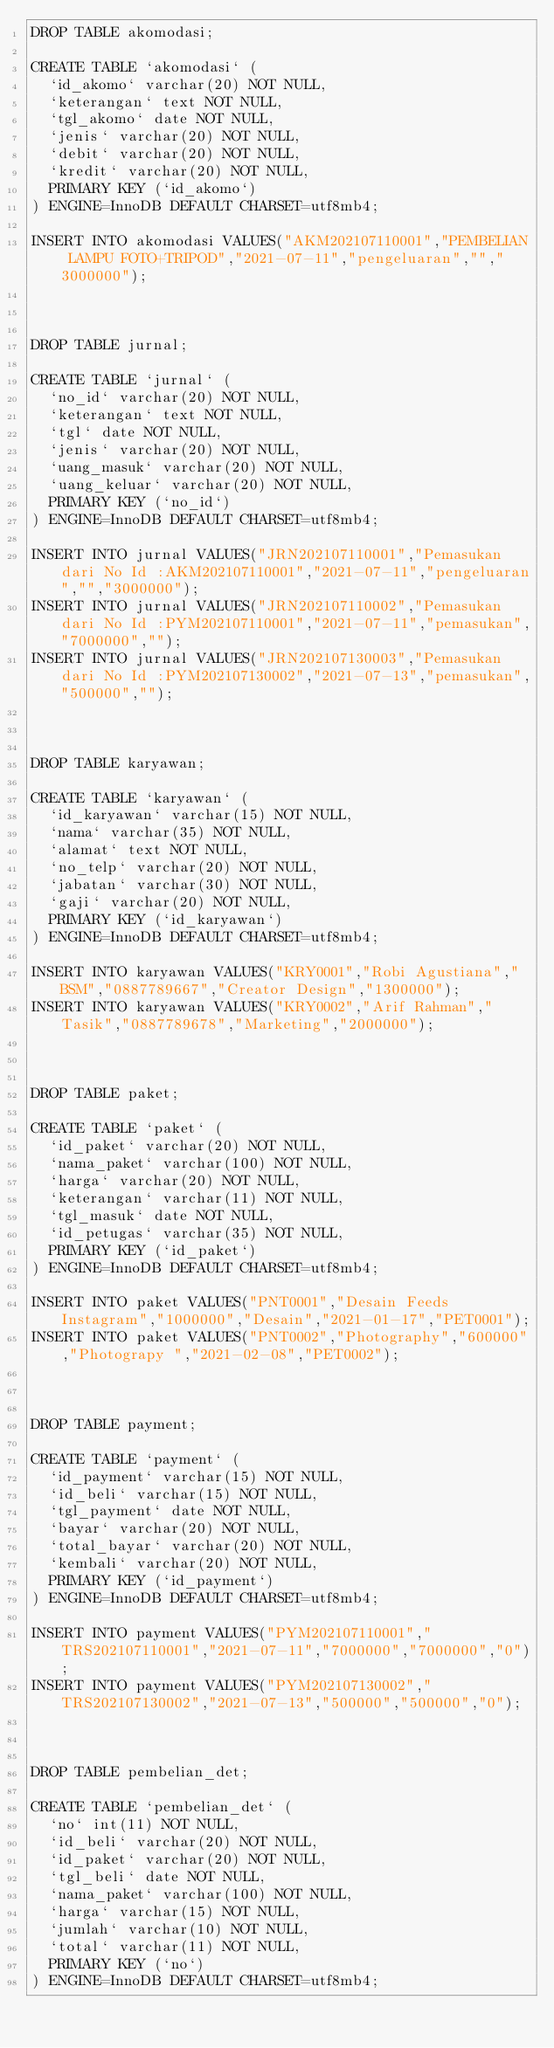Convert code to text. <code><loc_0><loc_0><loc_500><loc_500><_SQL_>DROP TABLE akomodasi;

CREATE TABLE `akomodasi` (
  `id_akomo` varchar(20) NOT NULL,
  `keterangan` text NOT NULL,
  `tgl_akomo` date NOT NULL,
  `jenis` varchar(20) NOT NULL,
  `debit` varchar(20) NOT NULL,
  `kredit` varchar(20) NOT NULL,
  PRIMARY KEY (`id_akomo`)
) ENGINE=InnoDB DEFAULT CHARSET=utf8mb4;

INSERT INTO akomodasi VALUES("AKM202107110001","PEMBELIAN LAMPU FOTO+TRIPOD","2021-07-11","pengeluaran","","3000000");



DROP TABLE jurnal;

CREATE TABLE `jurnal` (
  `no_id` varchar(20) NOT NULL,
  `keterangan` text NOT NULL,
  `tgl` date NOT NULL,
  `jenis` varchar(20) NOT NULL,
  `uang_masuk` varchar(20) NOT NULL,
  `uang_keluar` varchar(20) NOT NULL,
  PRIMARY KEY (`no_id`)
) ENGINE=InnoDB DEFAULT CHARSET=utf8mb4;

INSERT INTO jurnal VALUES("JRN202107110001","Pemasukan dari No Id :AKM202107110001","2021-07-11","pengeluaran","","3000000");
INSERT INTO jurnal VALUES("JRN202107110002","Pemasukan dari No Id :PYM202107110001","2021-07-11","pemasukan","7000000","");
INSERT INTO jurnal VALUES("JRN202107130003","Pemasukan dari No Id :PYM202107130002","2021-07-13","pemasukan","500000","");



DROP TABLE karyawan;

CREATE TABLE `karyawan` (
  `id_karyawan` varchar(15) NOT NULL,
  `nama` varchar(35) NOT NULL,
  `alamat` text NOT NULL,
  `no_telp` varchar(20) NOT NULL,
  `jabatan` varchar(30) NOT NULL,
  `gaji` varchar(20) NOT NULL,
  PRIMARY KEY (`id_karyawan`)
) ENGINE=InnoDB DEFAULT CHARSET=utf8mb4;

INSERT INTO karyawan VALUES("KRY0001","Robi Agustiana","BSM","0887789667","Creator Design","1300000");
INSERT INTO karyawan VALUES("KRY0002","Arif Rahman","Tasik","0887789678","Marketing","2000000");



DROP TABLE paket;

CREATE TABLE `paket` (
  `id_paket` varchar(20) NOT NULL,
  `nama_paket` varchar(100) NOT NULL,
  `harga` varchar(20) NOT NULL,
  `keterangan` varchar(11) NOT NULL,
  `tgl_masuk` date NOT NULL,
  `id_petugas` varchar(35) NOT NULL,
  PRIMARY KEY (`id_paket`)
) ENGINE=InnoDB DEFAULT CHARSET=utf8mb4;

INSERT INTO paket VALUES("PNT0001","Desain Feeds Instagram","1000000","Desain","2021-01-17","PET0001");
INSERT INTO paket VALUES("PNT0002","Photography","600000","Photograpy ","2021-02-08","PET0002");



DROP TABLE payment;

CREATE TABLE `payment` (
  `id_payment` varchar(15) NOT NULL,
  `id_beli` varchar(15) NOT NULL,
  `tgl_payment` date NOT NULL,
  `bayar` varchar(20) NOT NULL,
  `total_bayar` varchar(20) NOT NULL,
  `kembali` varchar(20) NOT NULL,
  PRIMARY KEY (`id_payment`)
) ENGINE=InnoDB DEFAULT CHARSET=utf8mb4;

INSERT INTO payment VALUES("PYM202107110001","TRS202107110001","2021-07-11","7000000","7000000","0");
INSERT INTO payment VALUES("PYM202107130002","TRS202107130002","2021-07-13","500000","500000","0");



DROP TABLE pembelian_det;

CREATE TABLE `pembelian_det` (
  `no` int(11) NOT NULL,
  `id_beli` varchar(20) NOT NULL,
  `id_paket` varchar(20) NOT NULL,
  `tgl_beli` date NOT NULL,
  `nama_paket` varchar(100) NOT NULL,
  `harga` varchar(15) NOT NULL,
  `jumlah` varchar(10) NOT NULL,
  `total` varchar(11) NOT NULL,
  PRIMARY KEY (`no`)
) ENGINE=InnoDB DEFAULT CHARSET=utf8mb4;
</code> 